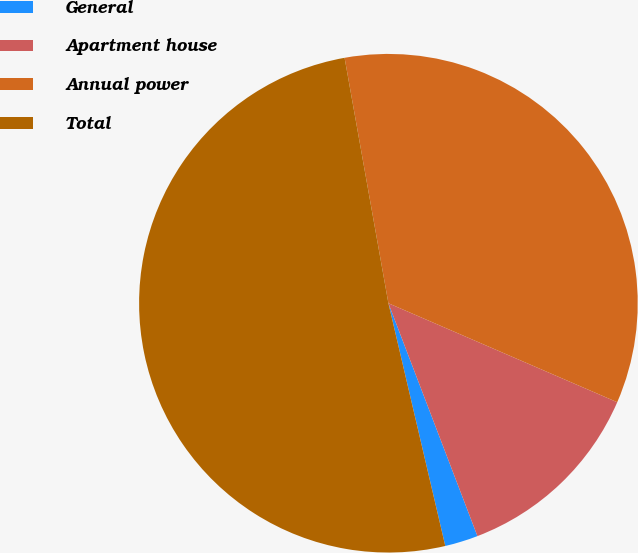Convert chart to OTSL. <chart><loc_0><loc_0><loc_500><loc_500><pie_chart><fcel>General<fcel>Apartment house<fcel>Annual power<fcel>Total<nl><fcel>2.15%<fcel>12.69%<fcel>34.31%<fcel>50.85%<nl></chart> 